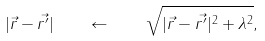Convert formula to latex. <formula><loc_0><loc_0><loc_500><loc_500>| \vec { r } - \vec { r ^ { \prime } } | \quad \leftarrow \quad \sqrt { | \vec { r } - \vec { r ^ { \prime } } | ^ { 2 } + \lambda ^ { 2 } } ,</formula> 